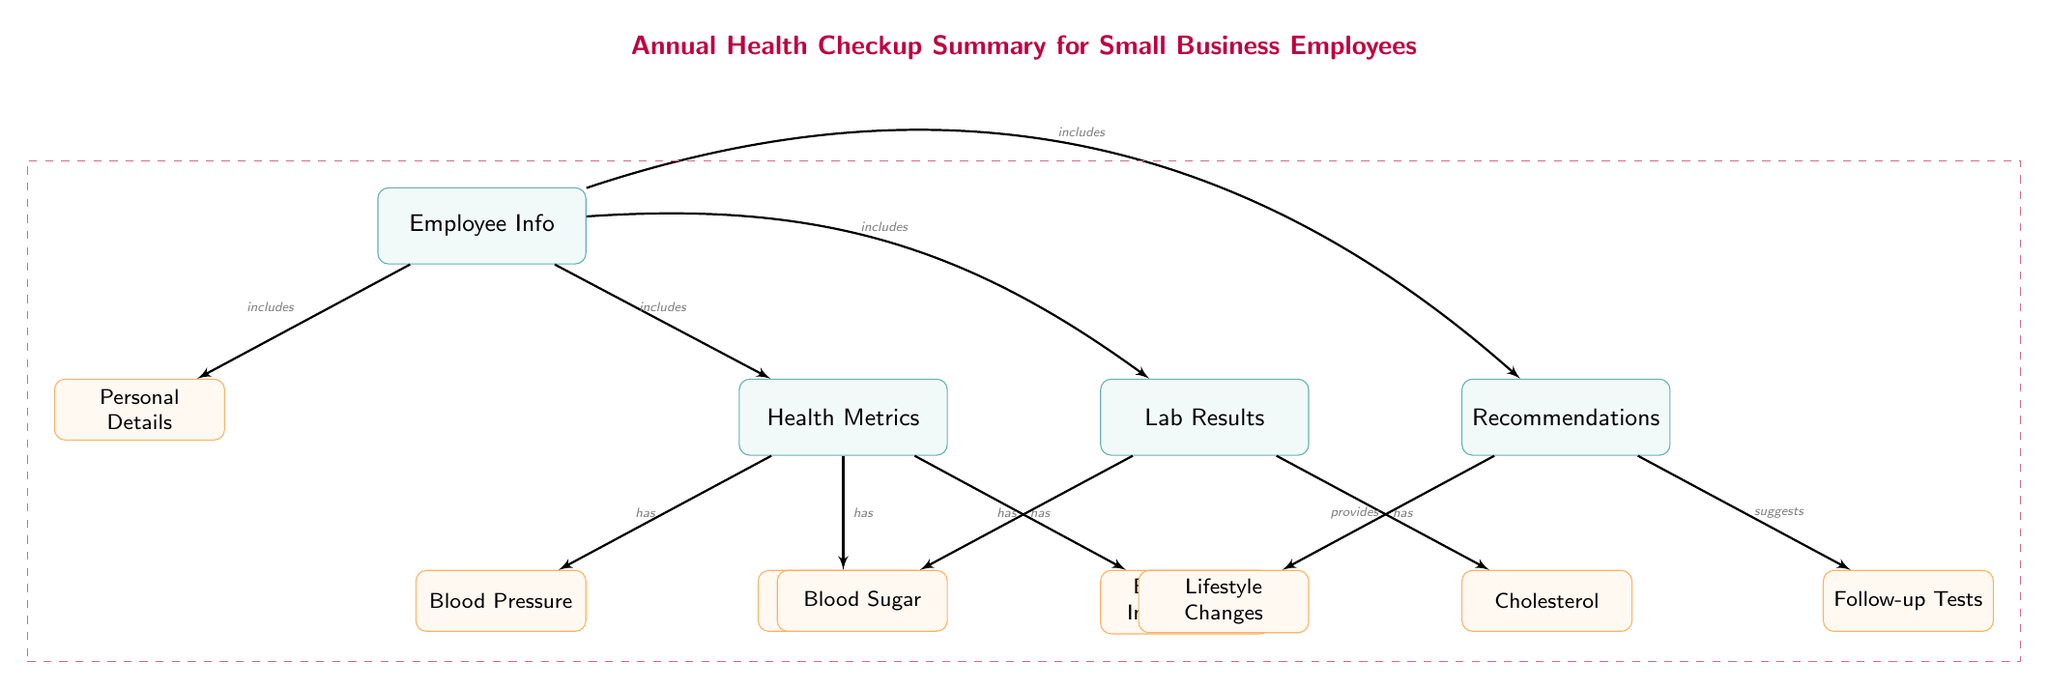What is included in Employee Info? The Employee Info node leads to two subnodes: Personal Details and Health Metrics. Since the question asks for what is included specifically under Employee Info, we look at its direct connections and find the two mentioned subnodes.
Answer: Personal Details, Health Metrics How many Health Metrics are listed? The Health Metrics node connects to three subnodes: Blood Pressure, Heart Rate, and Body Mass Index (BMI). Counting these three subnodes provides the answer needed for this question about Health Metrics.
Answer: 3 What does Lab Results include? Lab Results is connected to two subnodes: Blood Sugar and Cholesterol. The question requires identifying what Lab Results includes, which leads us to these two subnodes.
Answer: Blood Sugar, Cholesterol Which node provides recommendations? Recommendations is the mainnode that includes two subnodes, one of which is Lifestyle Changes, and the other is Follow-up Tests. To answer which node provides recommendations, we refer directly to the name of the mainnode, as this is what the question seeks.
Answer: Recommendations How does Health Metrics relate to Lab Results? The Health Metrics node is separated from the Lab Results node by a main connection; however, the relationship type is not directly observable since the Lab Results are not directly connected to the Health Metrics. Instead, it can be inferred that they are both components that fall under Employee Info.
Answer: No direct relationship What types of metrics are included in Health Metrics? Within the Health Metrics node, there are three specific subnodes: Blood Pressure, Heart Rate, and Body Mass Index (BMI). The question allows us to summarize the metrics directly mentioned in this part of the diagram.
Answer: Blood Pressure, Heart Rate, Body Mass Index What kind of changes does Recommendations suggest? The Recommendations node leads to a subnode called Follow-up Tests, in addition to another subnode called Lifestyle Changes. Since the focus is on what changes are suggested under Recommendations, it is essential to look only at the relevant subnodes and summarize them as the answer.
Answer: Lifestyle Changes, Follow-up Tests Which elements are included in the entire diagram? The complete diagram includes all mainnodes and subnodes, encompassing Employee Info, Health Metrics, Lab Results, and Recommendations along with their respective subnodes. Counting all nodes provides a comprehensive overview.
Answer: 12 nodes How many nodes are connected to Employee Info? Employee Info includes two direct subnodes and directly connects to three main categories: Health Metrics, Lab Results, and Recommendations. Counting all relevant connections leads to a total of five nodes linked to Employee Info.
Answer: 5 